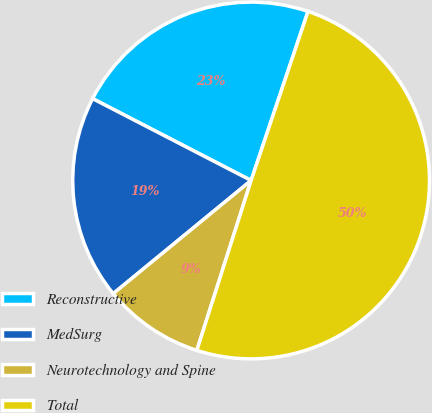Convert chart to OTSL. <chart><loc_0><loc_0><loc_500><loc_500><pie_chart><fcel>Reconstructive<fcel>MedSurg<fcel>Neurotechnology and Spine<fcel>Total<nl><fcel>22.58%<fcel>18.52%<fcel>9.14%<fcel>49.75%<nl></chart> 